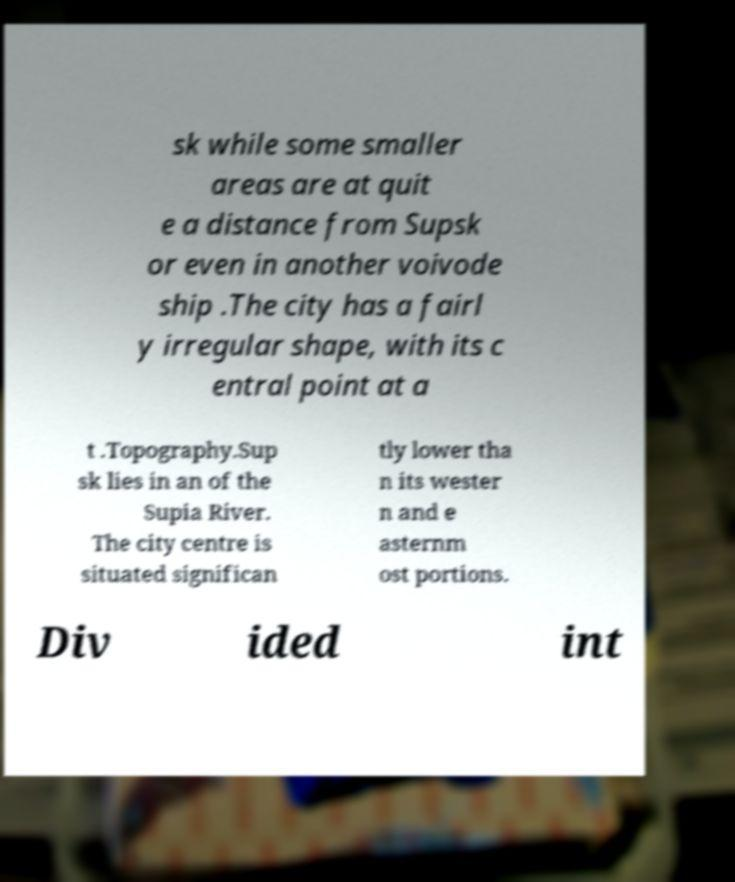I need the written content from this picture converted into text. Can you do that? sk while some smaller areas are at quit e a distance from Supsk or even in another voivode ship .The city has a fairl y irregular shape, with its c entral point at a t .Topography.Sup sk lies in an of the Supia River. The city centre is situated significan tly lower tha n its wester n and e asternm ost portions. Div ided int 